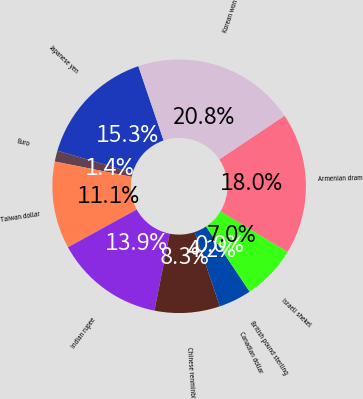Convert chart. <chart><loc_0><loc_0><loc_500><loc_500><pie_chart><fcel>Japanese yen<fcel>Euro<fcel>Taiwan dollar<fcel>Indian rupee<fcel>Chinese renminbi<fcel>Canadian dollar<fcel>British pound sterling<fcel>Israeli shekel<fcel>Armenian dram<fcel>Korean won<nl><fcel>15.27%<fcel>1.4%<fcel>11.11%<fcel>13.89%<fcel>8.33%<fcel>4.17%<fcel>0.01%<fcel>6.95%<fcel>18.05%<fcel>20.82%<nl></chart> 